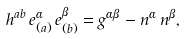<formula> <loc_0><loc_0><loc_500><loc_500>h ^ { a b } \, e ^ { \alpha } _ { ( a ) } \, e ^ { \beta } _ { ( b ) } = g ^ { \alpha \beta } - n ^ { \alpha } \, n ^ { \beta } ,</formula> 